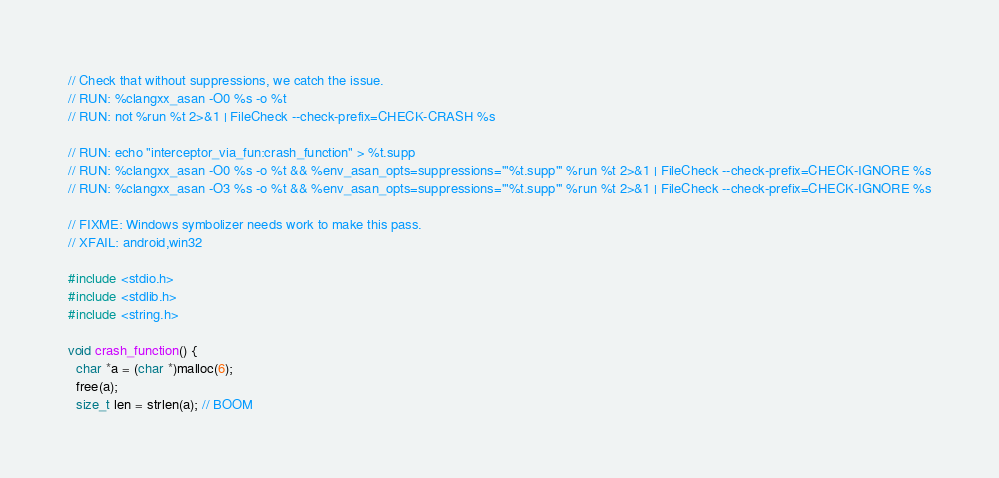Convert code to text. <code><loc_0><loc_0><loc_500><loc_500><_C++_>// Check that without suppressions, we catch the issue.
// RUN: %clangxx_asan -O0 %s -o %t
// RUN: not %run %t 2>&1 | FileCheck --check-prefix=CHECK-CRASH %s

// RUN: echo "interceptor_via_fun:crash_function" > %t.supp
// RUN: %clangxx_asan -O0 %s -o %t && %env_asan_opts=suppressions='"%t.supp"' %run %t 2>&1 | FileCheck --check-prefix=CHECK-IGNORE %s
// RUN: %clangxx_asan -O3 %s -o %t && %env_asan_opts=suppressions='"%t.supp"' %run %t 2>&1 | FileCheck --check-prefix=CHECK-IGNORE %s

// FIXME: Windows symbolizer needs work to make this pass.
// XFAIL: android,win32

#include <stdio.h>
#include <stdlib.h>
#include <string.h>

void crash_function() {
  char *a = (char *)malloc(6);
  free(a);
  size_t len = strlen(a); // BOOM</code> 